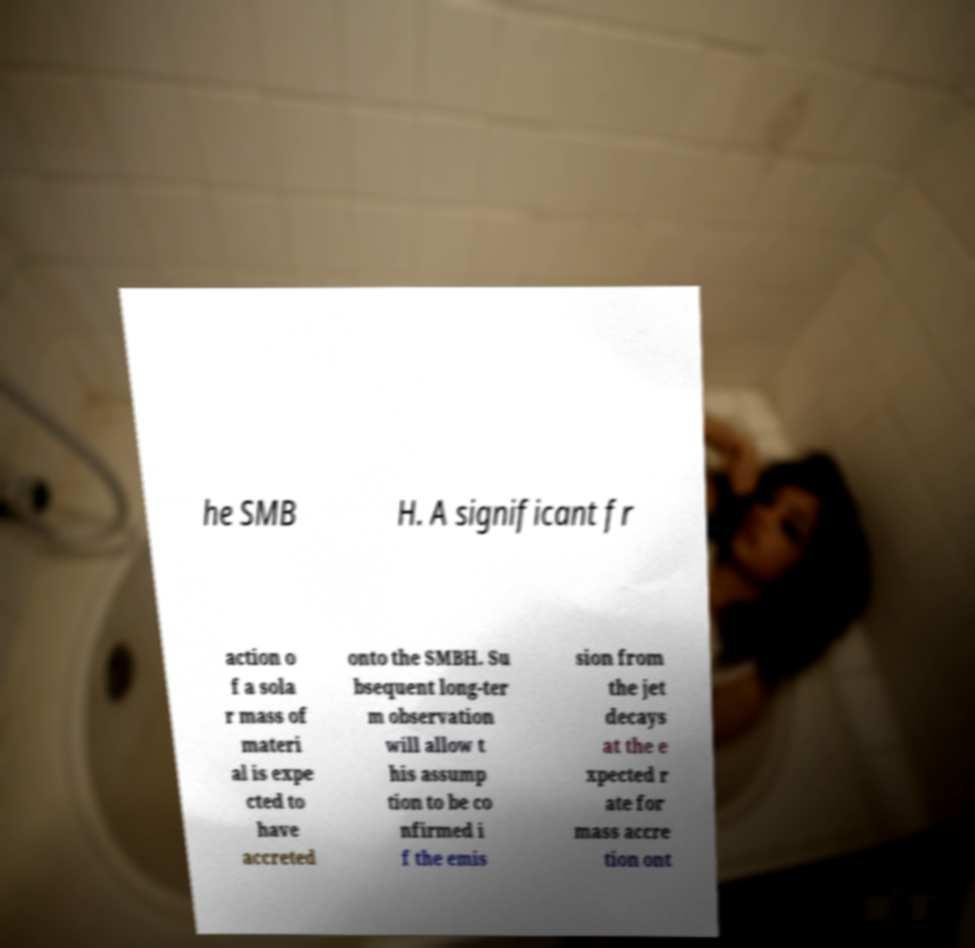Can you accurately transcribe the text from the provided image for me? he SMB H. A significant fr action o f a sola r mass of materi al is expe cted to have accreted onto the SMBH. Su bsequent long-ter m observation will allow t his assump tion to be co nfirmed i f the emis sion from the jet decays at the e xpected r ate for mass accre tion ont 